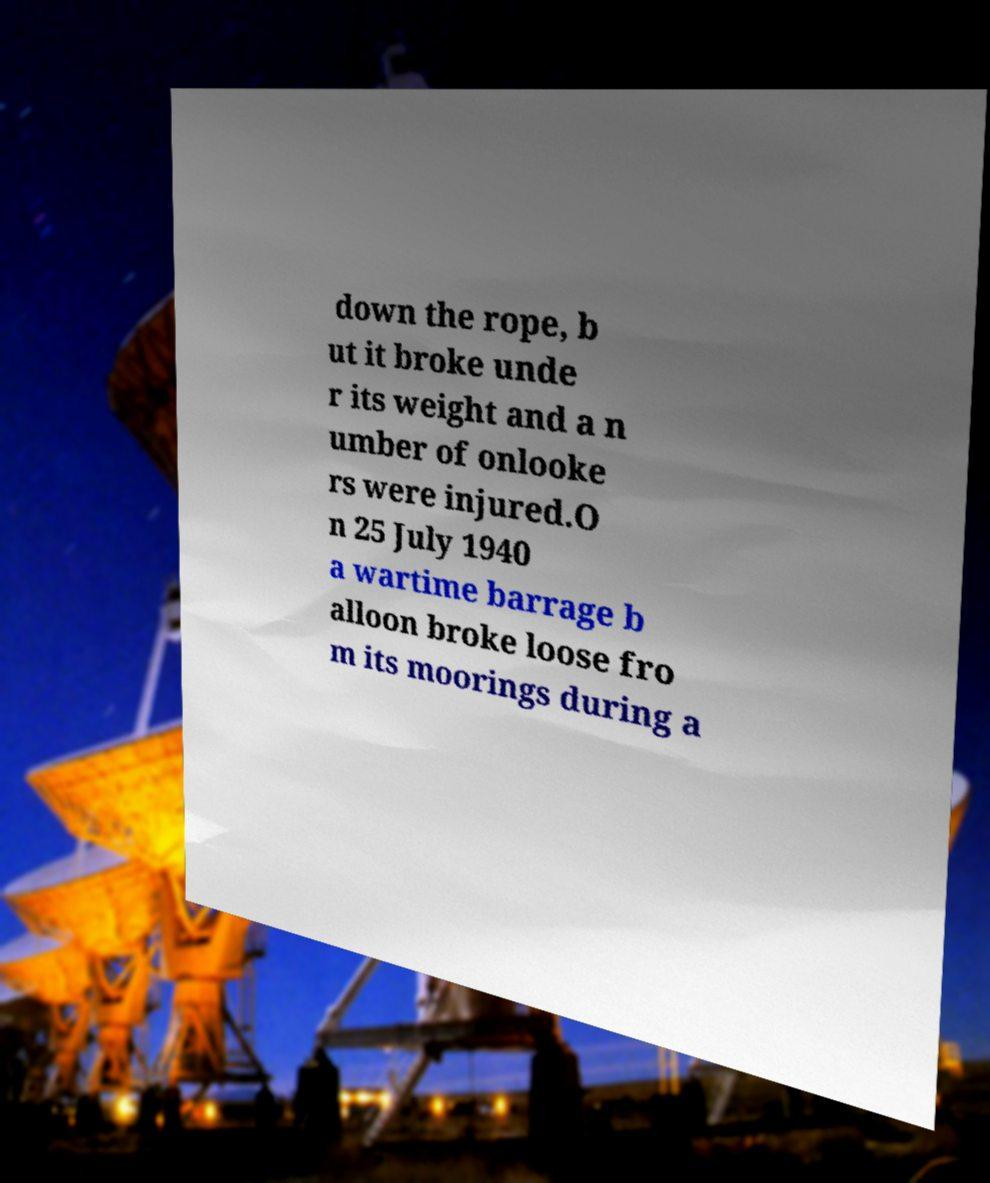There's text embedded in this image that I need extracted. Can you transcribe it verbatim? down the rope, b ut it broke unde r its weight and a n umber of onlooke rs were injured.O n 25 July 1940 a wartime barrage b alloon broke loose fro m its moorings during a 